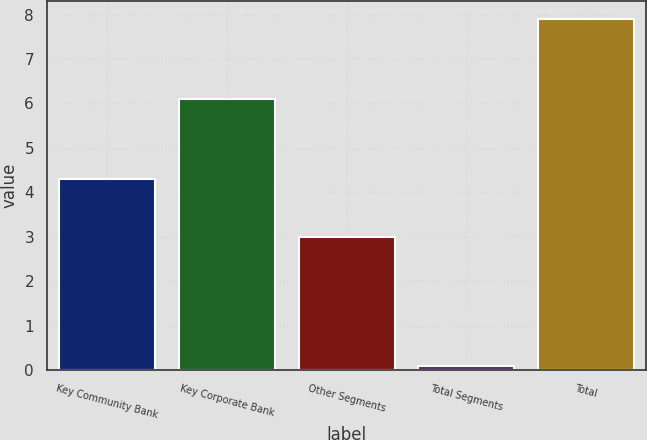Convert chart to OTSL. <chart><loc_0><loc_0><loc_500><loc_500><bar_chart><fcel>Key Community Bank<fcel>Key Corporate Bank<fcel>Other Segments<fcel>Total Segments<fcel>Total<nl><fcel>4.3<fcel>6.1<fcel>3<fcel>0.1<fcel>7.9<nl></chart> 